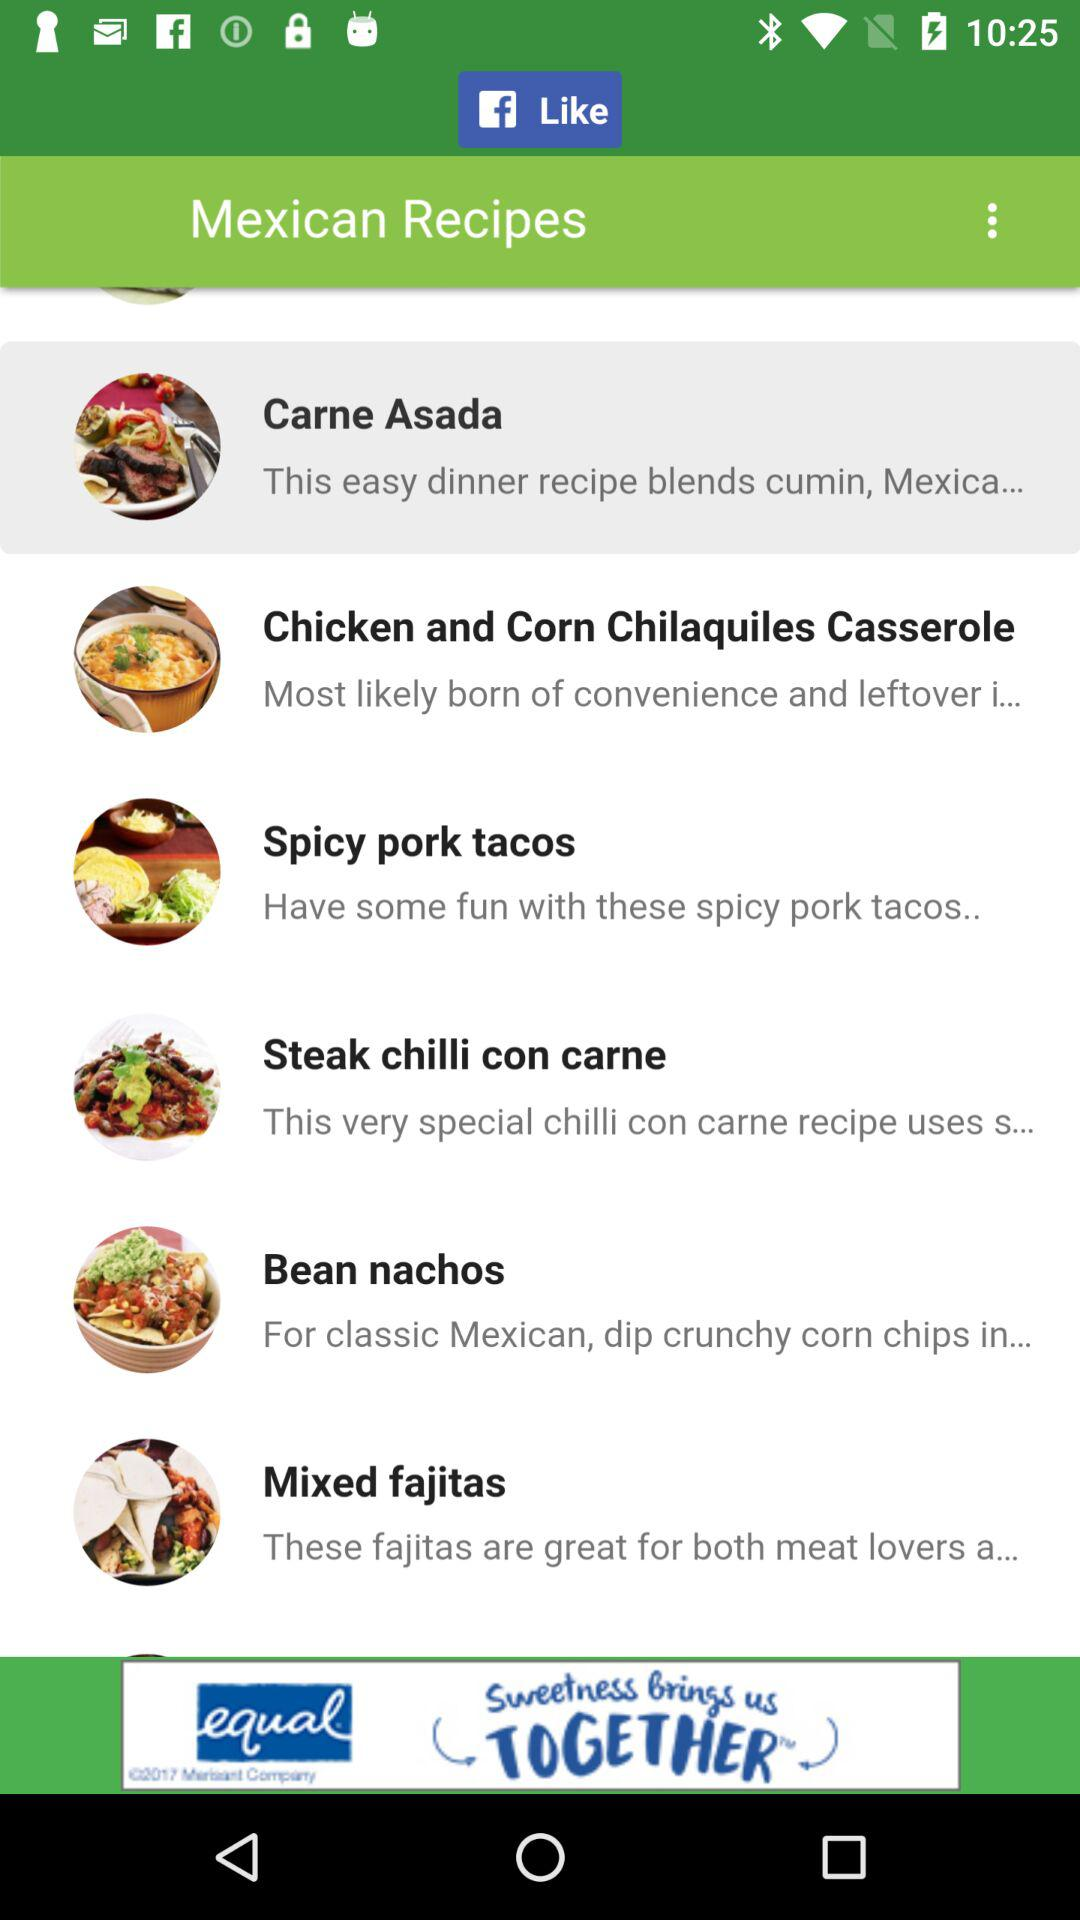What are the different available Mexican recipes? The different available Mexican recipes are "Carne Asada", "Chicken and Corn Chilaquiles Casserole", "Spicy pork tacos", "Steak chilli con carne", "Bean nachos" and "Mixed fajitas". 